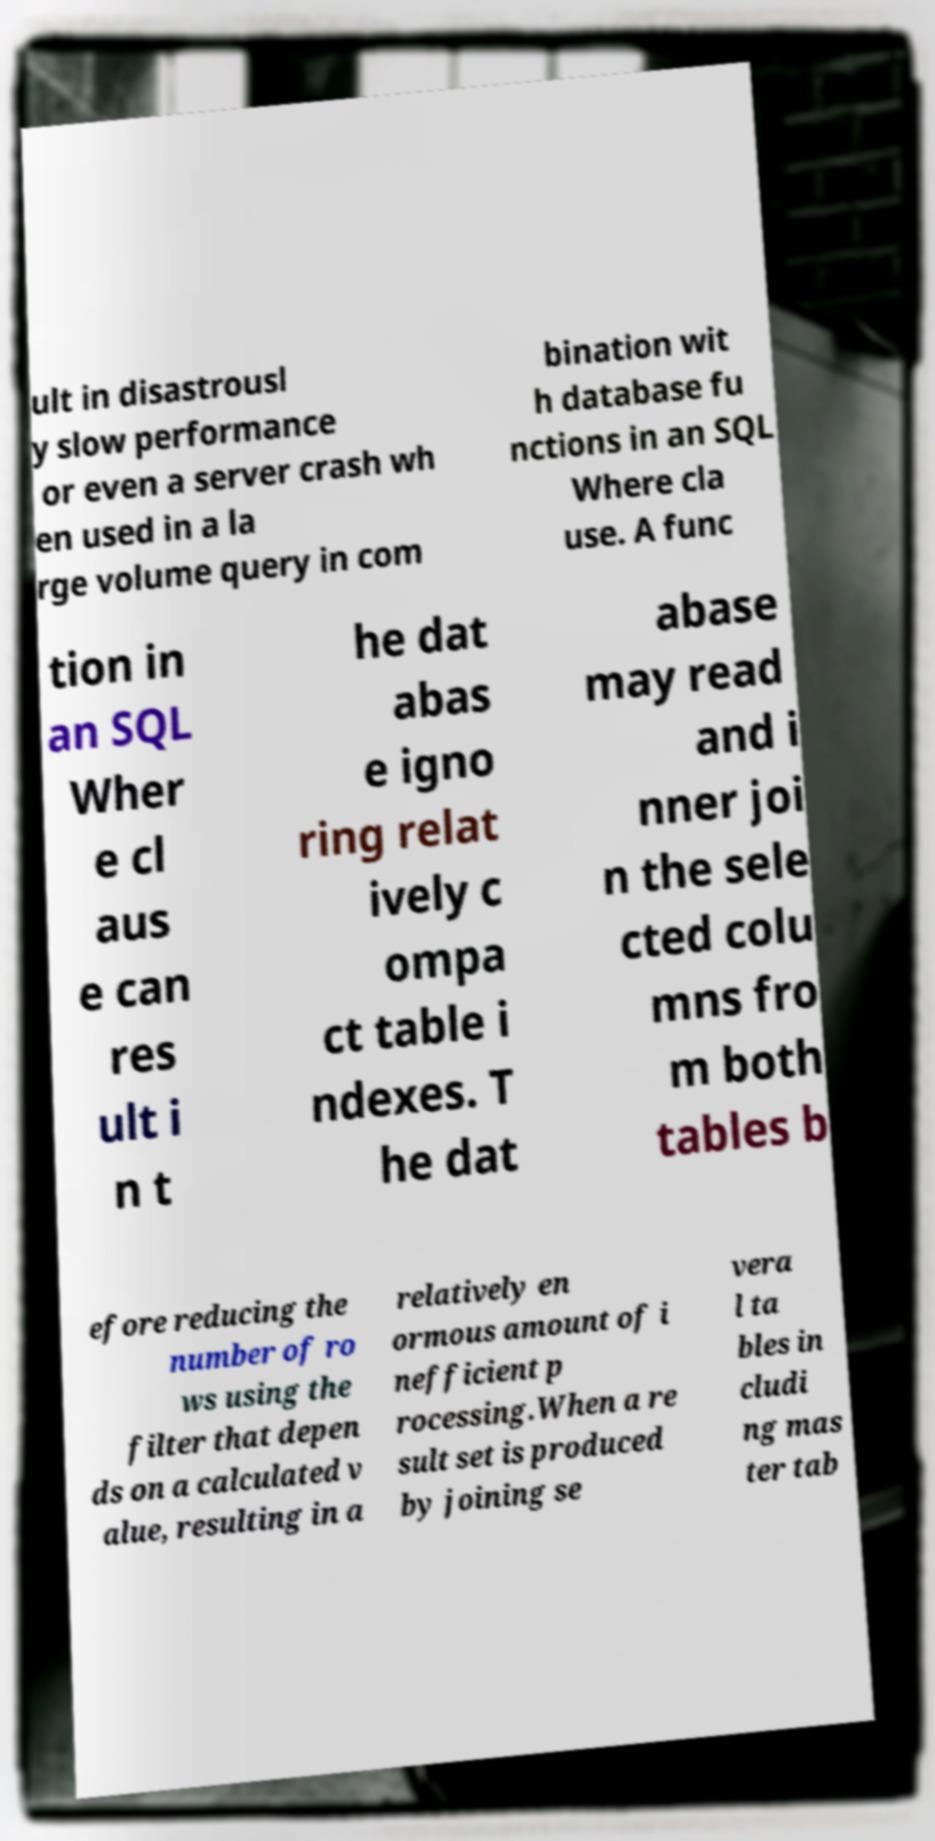There's text embedded in this image that I need extracted. Can you transcribe it verbatim? ult in disastrousl y slow performance or even a server crash wh en used in a la rge volume query in com bination wit h database fu nctions in an SQL Where cla use. A func tion in an SQL Wher e cl aus e can res ult i n t he dat abas e igno ring relat ively c ompa ct table i ndexes. T he dat abase may read and i nner joi n the sele cted colu mns fro m both tables b efore reducing the number of ro ws using the filter that depen ds on a calculated v alue, resulting in a relatively en ormous amount of i nefficient p rocessing.When a re sult set is produced by joining se vera l ta bles in cludi ng mas ter tab 